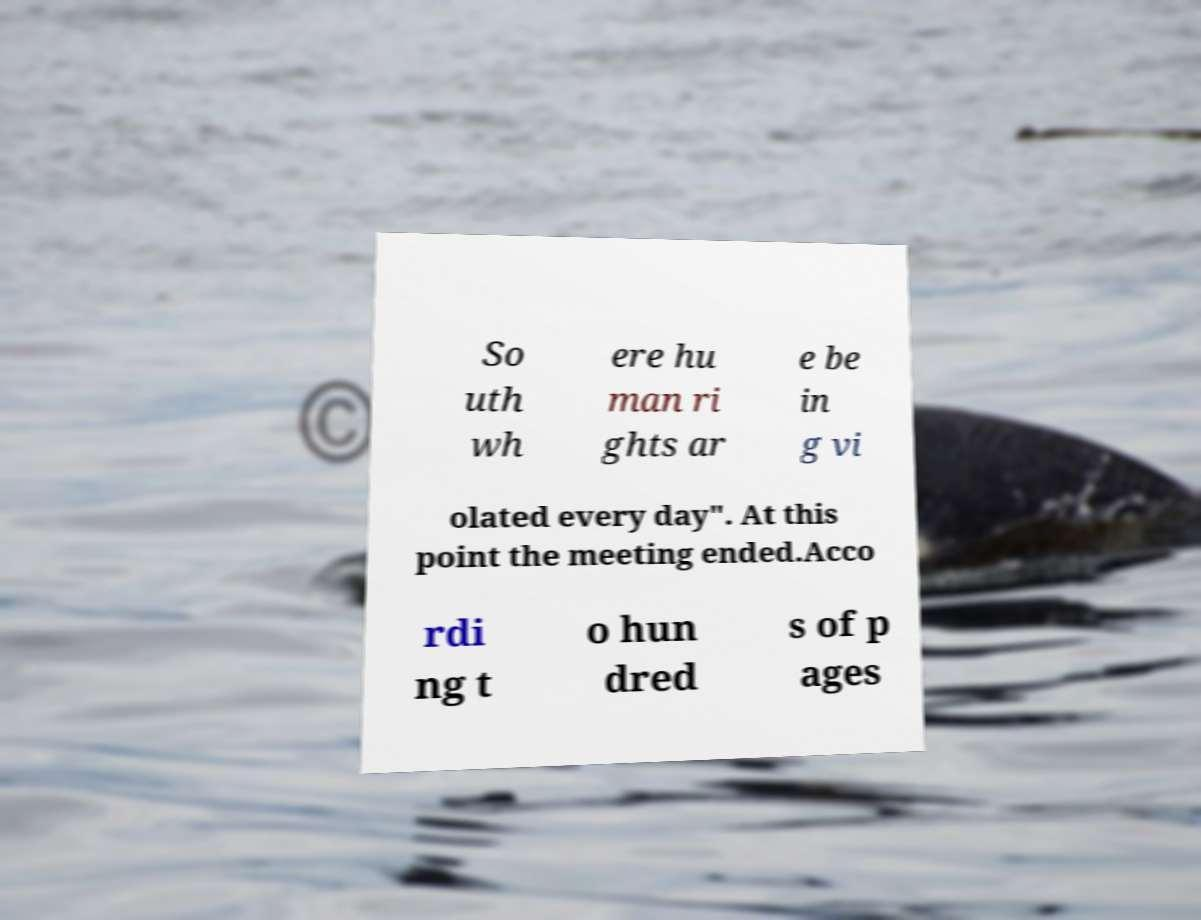I need the written content from this picture converted into text. Can you do that? So uth wh ere hu man ri ghts ar e be in g vi olated every day". At this point the meeting ended.Acco rdi ng t o hun dred s of p ages 